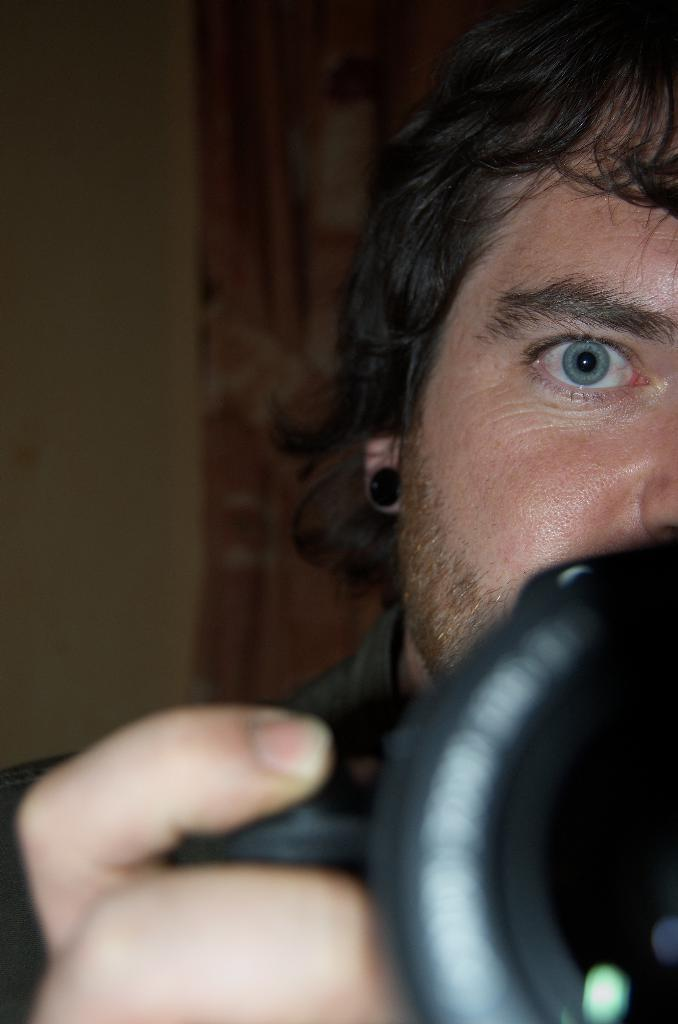Who is present in the image? There is a man in the image. What is the man holding in the image? The man is holding a camera. Can you see any fairies flying around the man in the image? There are no fairies present in the image. 